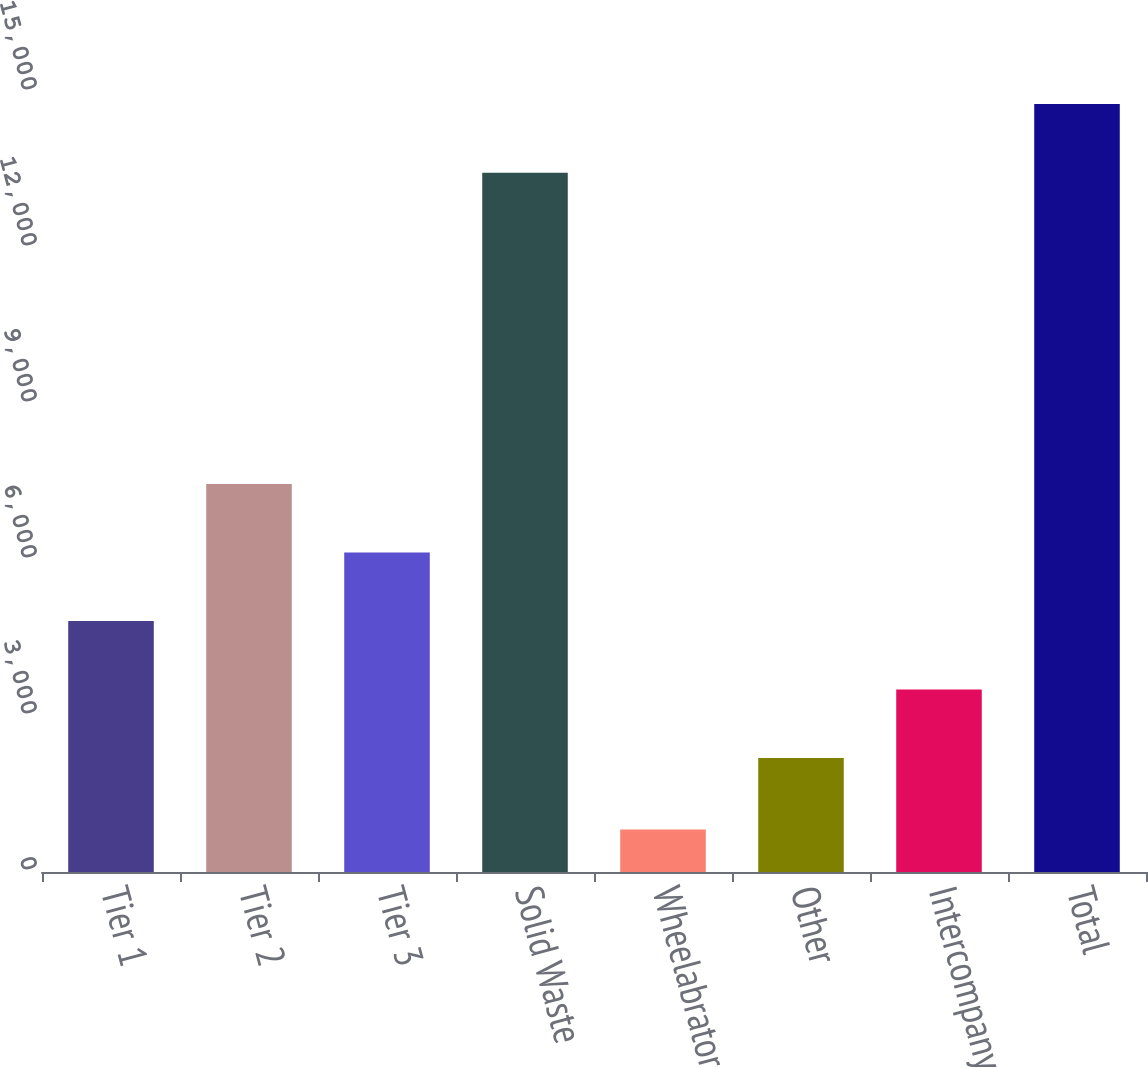Convert chart. <chart><loc_0><loc_0><loc_500><loc_500><bar_chart><fcel>Tier 1<fcel>Tier 2<fcel>Tier 3<fcel>Solid Waste<fcel>Wheelabrator<fcel>Other<fcel>Intercompany<fcel>Total<nl><fcel>4826.8<fcel>7462.6<fcel>6144.7<fcel>13449<fcel>817<fcel>2191<fcel>3508.9<fcel>14766.9<nl></chart> 